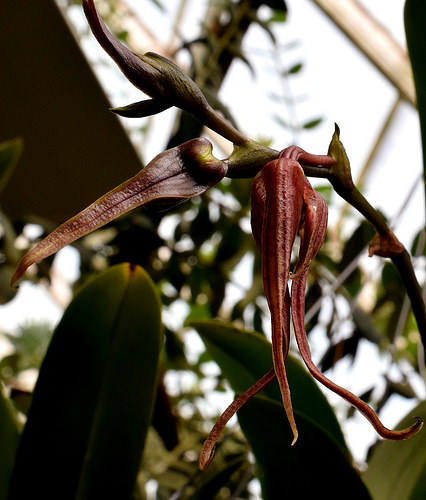<image>
Is the flower behind the flower two? Yes. From this viewpoint, the flower is positioned behind the flower two, with the flower two partially or fully occluding the flower. 